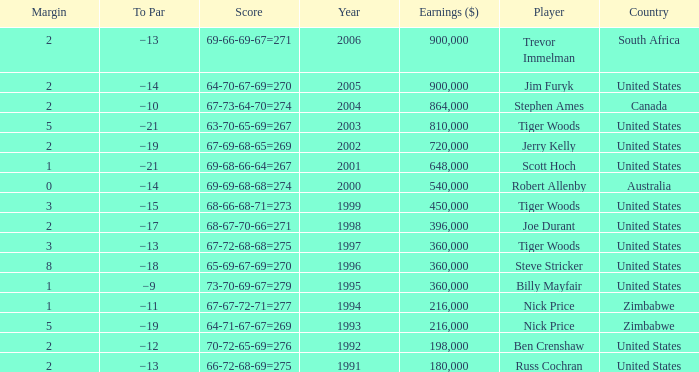Which Margin has a Country of united states, and a Score of 63-70-65-69=267? 5.0. 